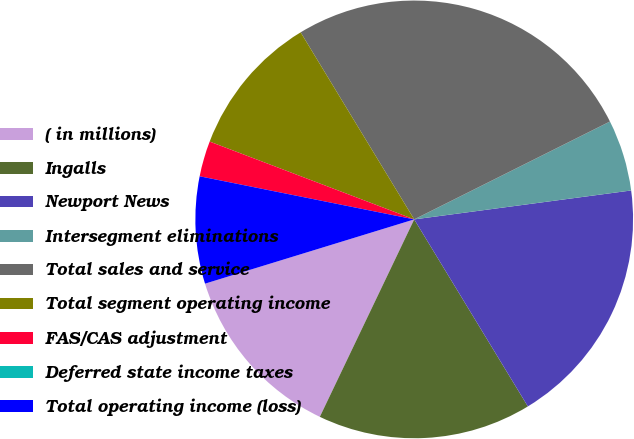<chart> <loc_0><loc_0><loc_500><loc_500><pie_chart><fcel>( in millions)<fcel>Ingalls<fcel>Newport News<fcel>Intersegment eliminations<fcel>Total sales and service<fcel>Total segment operating income<fcel>FAS/CAS adjustment<fcel>Deferred state income taxes<fcel>Total operating income (loss)<nl><fcel>13.16%<fcel>15.79%<fcel>18.42%<fcel>5.27%<fcel>26.31%<fcel>10.53%<fcel>2.63%<fcel>0.0%<fcel>7.9%<nl></chart> 